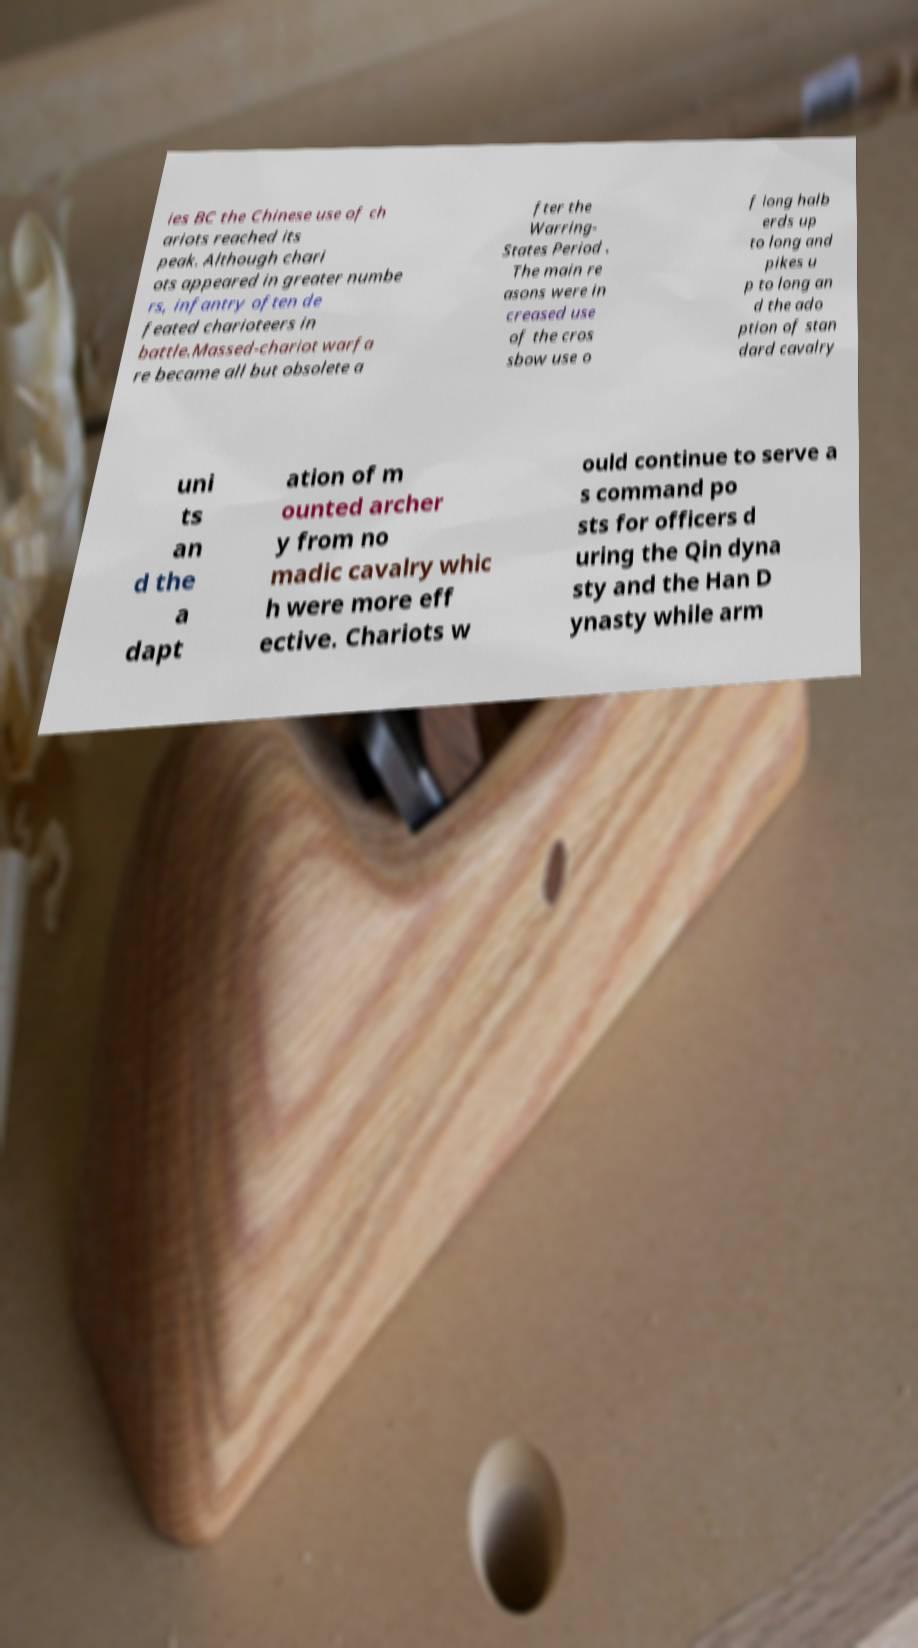Can you read and provide the text displayed in the image?This photo seems to have some interesting text. Can you extract and type it out for me? ies BC the Chinese use of ch ariots reached its peak. Although chari ots appeared in greater numbe rs, infantry often de feated charioteers in battle.Massed-chariot warfa re became all but obsolete a fter the Warring- States Period . The main re asons were in creased use of the cros sbow use o f long halb erds up to long and pikes u p to long an d the ado ption of stan dard cavalry uni ts an d the a dapt ation of m ounted archer y from no madic cavalry whic h were more eff ective. Chariots w ould continue to serve a s command po sts for officers d uring the Qin dyna sty and the Han D ynasty while arm 